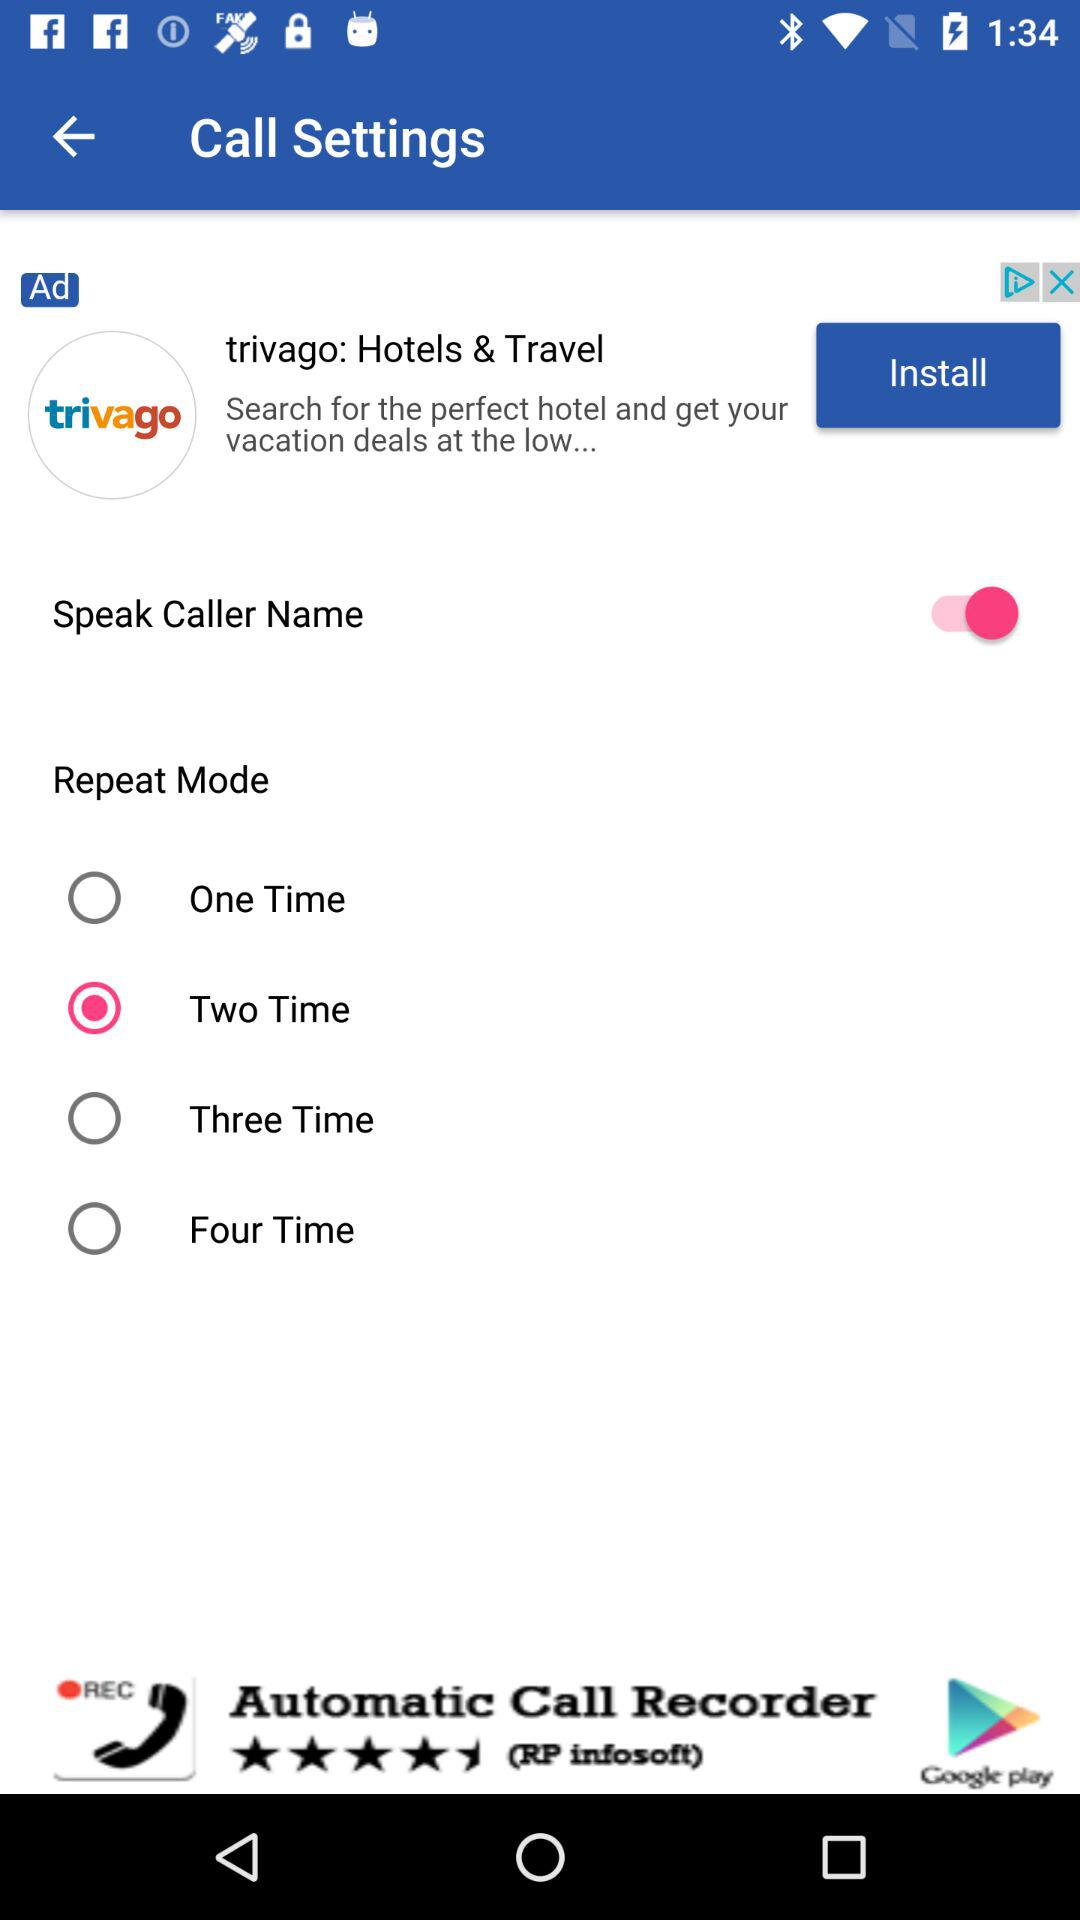Which "Repeat Mode" is selected? The selected repeat mode is "Two Time". 